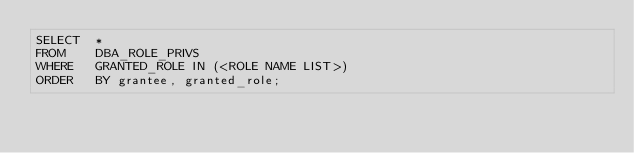Convert code to text. <code><loc_0><loc_0><loc_500><loc_500><_SQL_>SELECT  * 
FROM    DBA_ROLE_PRIVS 
WHERE   GRANTED_ROLE IN (<ROLE NAME LIST>) 
ORDER   BY grantee, granted_role;</code> 